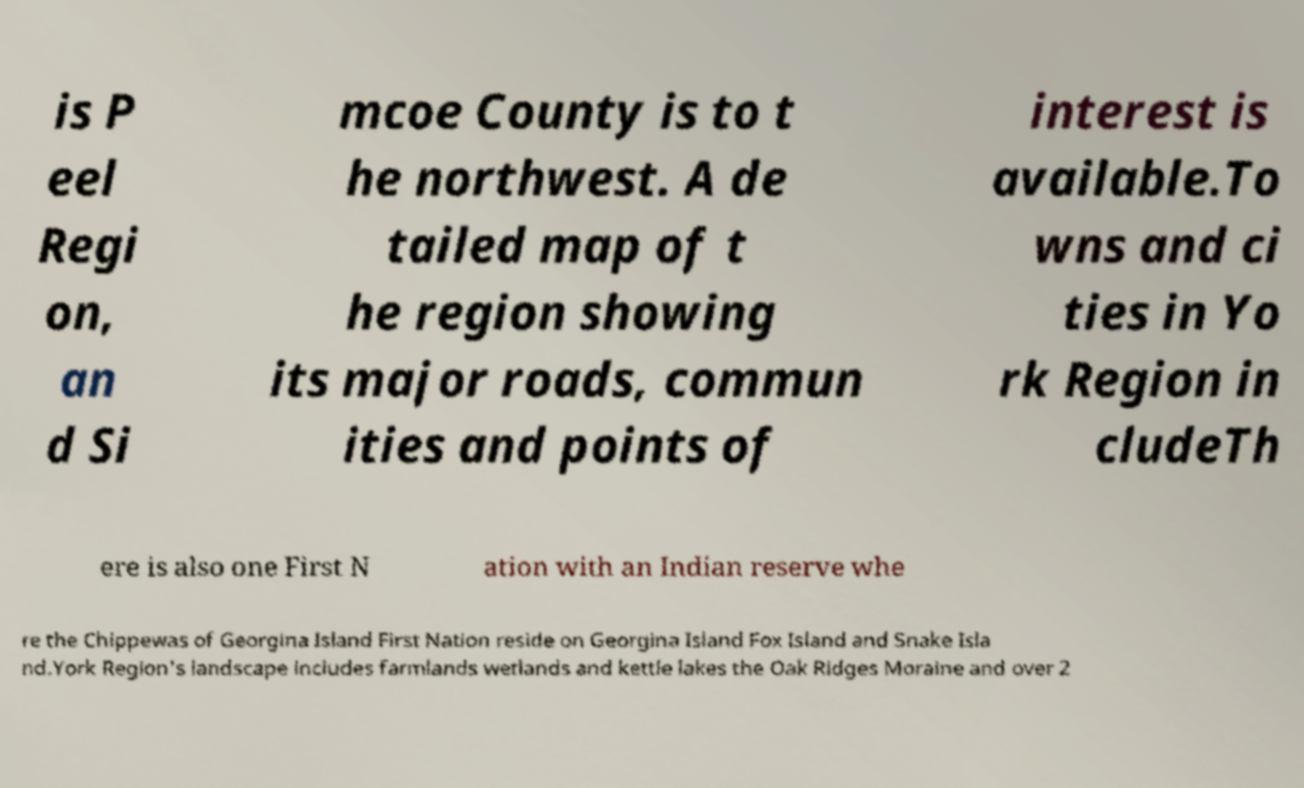Could you assist in decoding the text presented in this image and type it out clearly? is P eel Regi on, an d Si mcoe County is to t he northwest. A de tailed map of t he region showing its major roads, commun ities and points of interest is available.To wns and ci ties in Yo rk Region in cludeTh ere is also one First N ation with an Indian reserve whe re the Chippewas of Georgina Island First Nation reside on Georgina Island Fox Island and Snake Isla nd.York Region's landscape includes farmlands wetlands and kettle lakes the Oak Ridges Moraine and over 2 